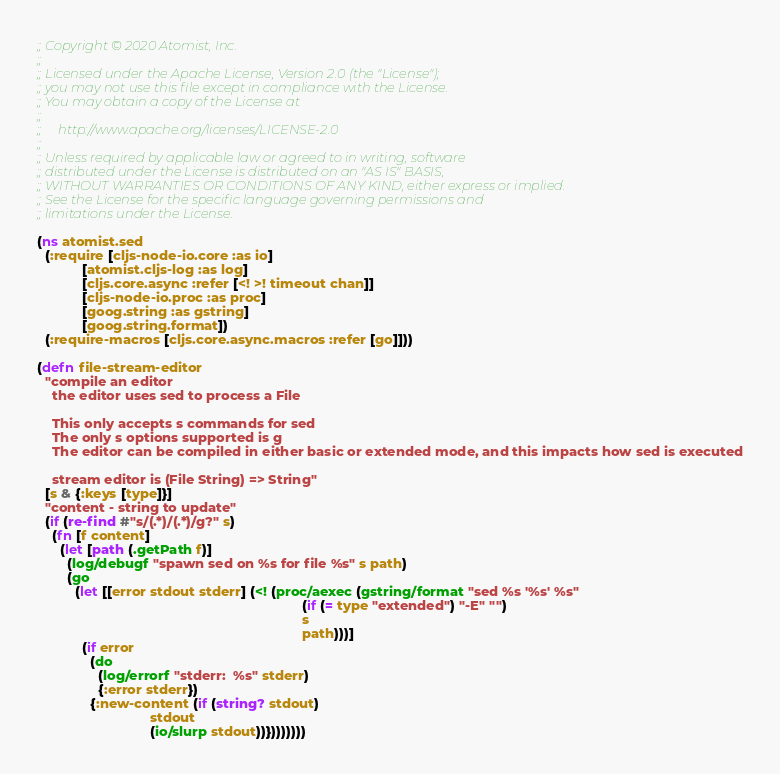<code> <loc_0><loc_0><loc_500><loc_500><_Clojure_>;; Copyright © 2020 Atomist, Inc.
;;
;; Licensed under the Apache License, Version 2.0 (the "License");
;; you may not use this file except in compliance with the License.
;; You may obtain a copy of the License at
;;
;;     http://www.apache.org/licenses/LICENSE-2.0
;;
;; Unless required by applicable law or agreed to in writing, software
;; distributed under the License is distributed on an "AS IS" BASIS,
;; WITHOUT WARRANTIES OR CONDITIONS OF ANY KIND, either express or implied.
;; See the License for the specific language governing permissions and
;; limitations under the License.

(ns atomist.sed
  (:require [cljs-node-io.core :as io]
            [atomist.cljs-log :as log]
            [cljs.core.async :refer [<! >! timeout chan]]
            [cljs-node-io.proc :as proc]
            [goog.string :as gstring]
            [goog.string.format])
  (:require-macros [cljs.core.async.macros :refer [go]]))

(defn file-stream-editor
  "compile an editor
    the editor uses sed to process a File

    This only accepts s commands for sed
    The only s options supported is g
    The editor can be compiled in either basic or extended mode, and this impacts how sed is executed

    stream editor is (File String) => String"
  [s & {:keys [type]}]
  "content - string to update"
  (if (re-find #"s/(.*)/(.*)/g?" s)
    (fn [f content]
      (let [path (.getPath f)]
        (log/debugf "spawn sed on %s for file %s" s path)
        (go
          (let [[error stdout stderr] (<! (proc/aexec (gstring/format "sed %s '%s' %s"
                                                                      (if (= type "extended") "-E" "")
                                                                      s
                                                                      path)))]
            (if error
              (do
                (log/errorf "stderr:  %s" stderr)
                {:error stderr})
              {:new-content (if (string? stdout)
                              stdout
                              (io/slurp stdout))})))))))
</code> 